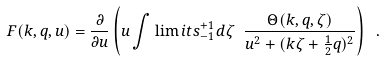Convert formula to latex. <formula><loc_0><loc_0><loc_500><loc_500>F ( k , q , u ) = \frac { \partial } { \partial u } \left ( u \int \lim i t s _ { - 1 } ^ { + 1 } d \zeta \ \frac { \Theta ( k , q , \zeta ) } { u ^ { 2 } + ( k \zeta + \frac { 1 } { 2 } q ) ^ { 2 } } \right ) \ .</formula> 